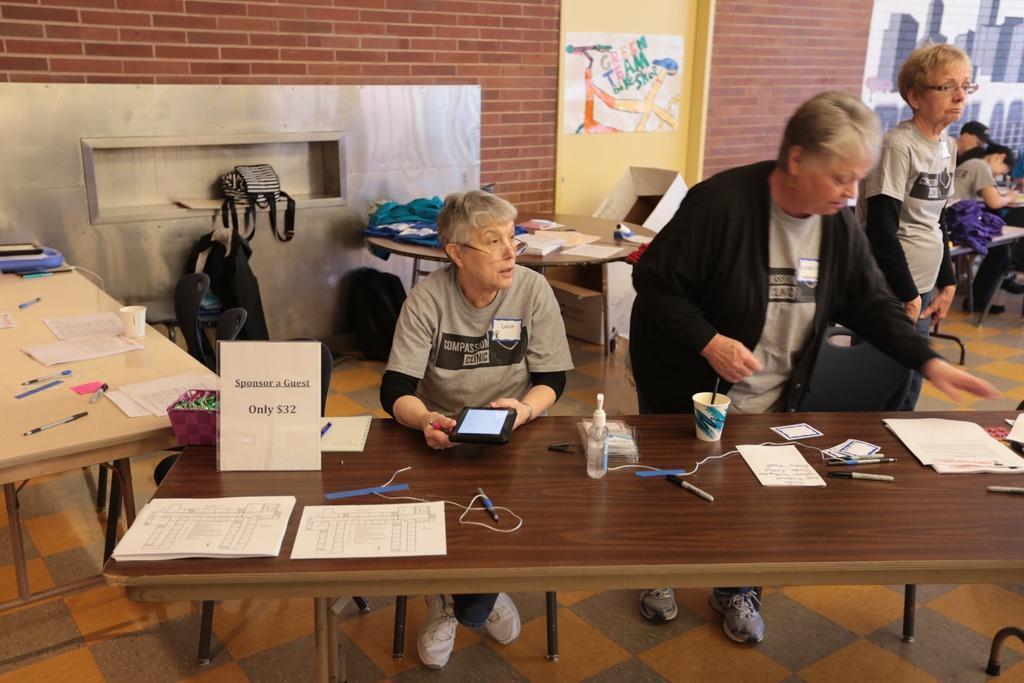How would you summarize this image in a sentence or two? In this image I see 3 women, in which one of them is sitting and rest of them are standing, I can also see few tables over here on which there are few things. In the background I see few more people and the wall. 